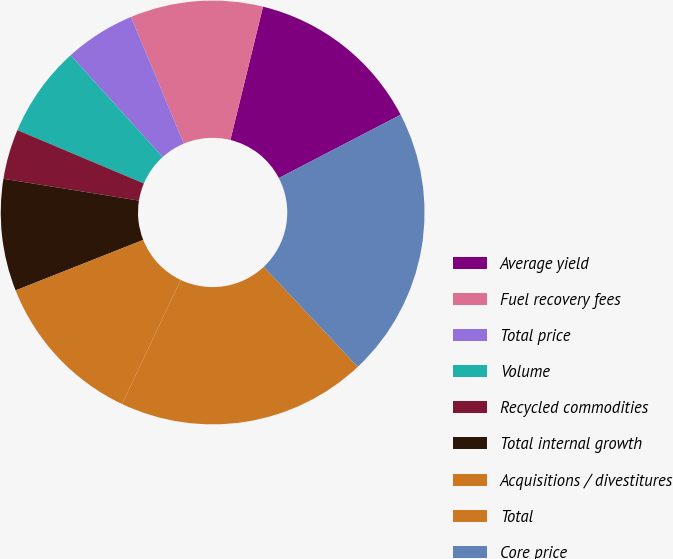Convert chart. <chart><loc_0><loc_0><loc_500><loc_500><pie_chart><fcel>Average yield<fcel>Fuel recovery fees<fcel>Total price<fcel>Volume<fcel>Recycled commodities<fcel>Total internal growth<fcel>Acquisitions / divestitures<fcel>Total<fcel>Core price<nl><fcel>13.55%<fcel>10.12%<fcel>5.39%<fcel>6.96%<fcel>3.81%<fcel>8.54%<fcel>11.97%<fcel>19.04%<fcel>20.62%<nl></chart> 